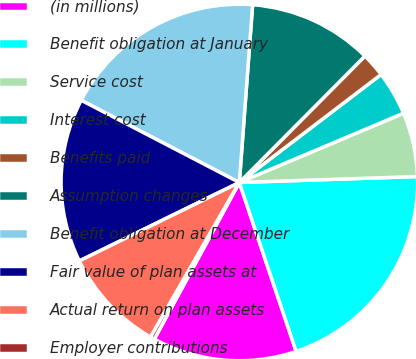<chart> <loc_0><loc_0><loc_500><loc_500><pie_chart><fcel>(in millions)<fcel>Benefit obligation at January<fcel>Service cost<fcel>Interest cost<fcel>Benefits paid<fcel>Assumption changes<fcel>Benefit obligation at December<fcel>Fair value of plan assets at<fcel>Actual return on plan assets<fcel>Employer contributions<nl><fcel>13.08%<fcel>20.37%<fcel>5.82%<fcel>4.01%<fcel>2.19%<fcel>11.26%<fcel>18.56%<fcel>14.89%<fcel>9.45%<fcel>0.38%<nl></chart> 